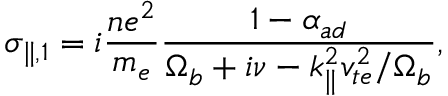<formula> <loc_0><loc_0><loc_500><loc_500>\sigma _ { \| , 1 } = i \frac { n e ^ { 2 } } { m _ { e } } \frac { 1 - \alpha _ { a d } } { \Omega _ { b } + i \nu - k _ { \| } ^ { 2 } v _ { t e } ^ { 2 } / \Omega _ { b } } ,</formula> 